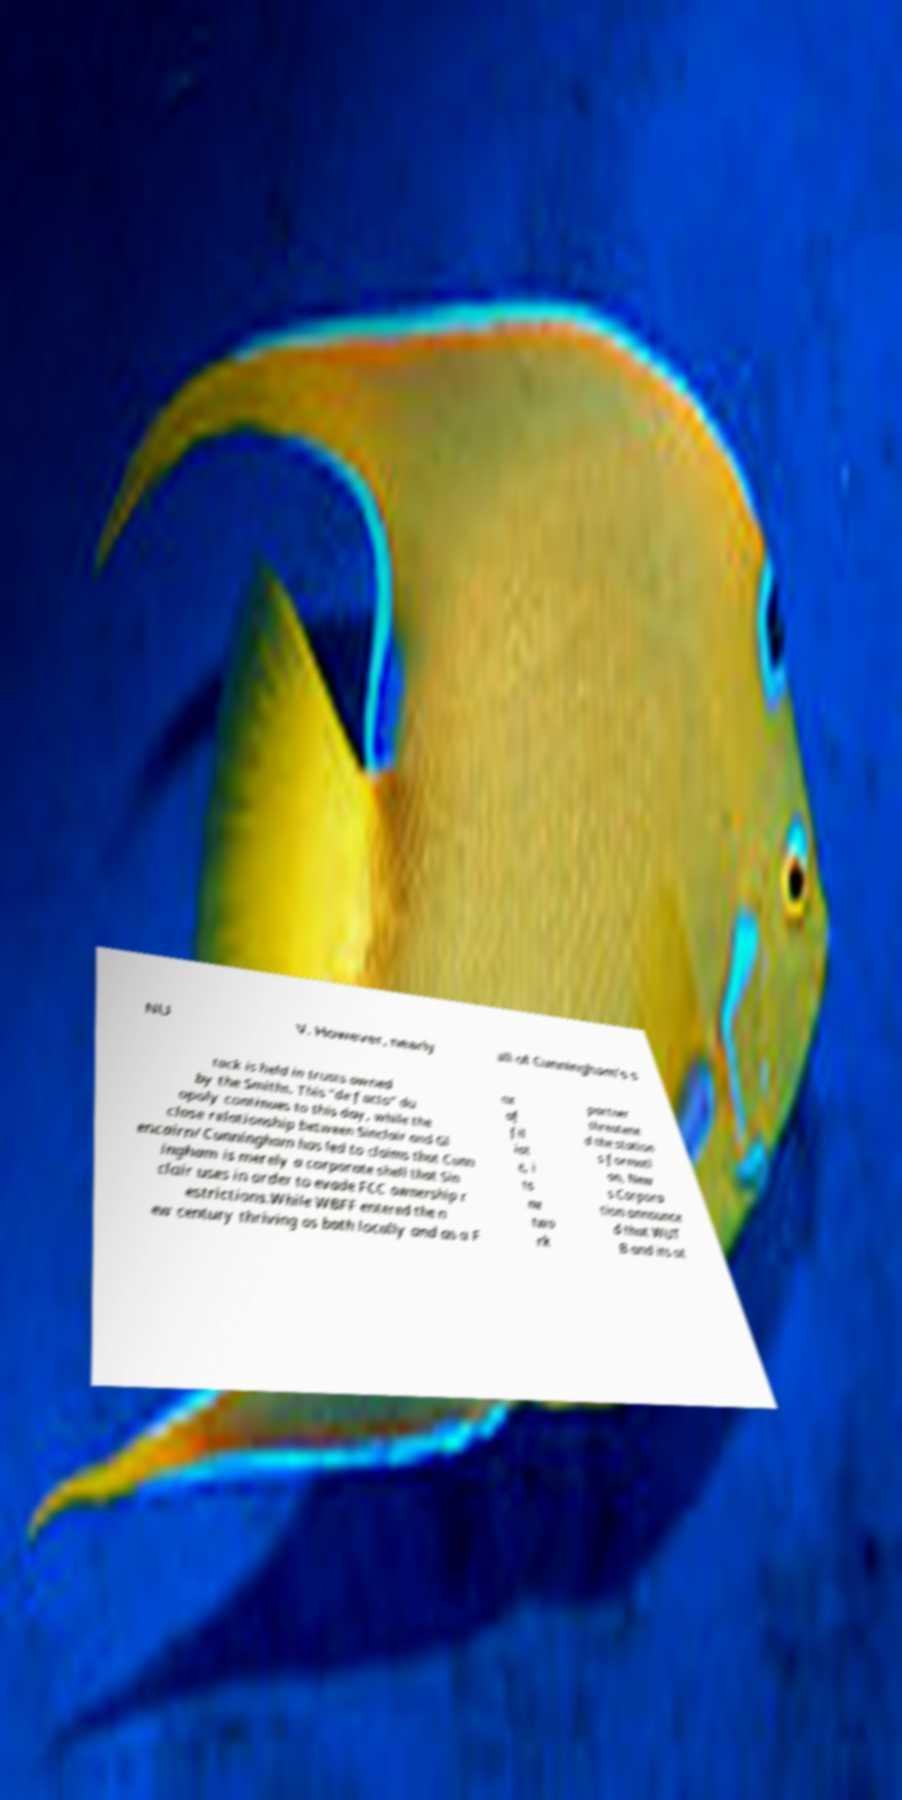Please identify and transcribe the text found in this image. NU V. However, nearly all of Cunningham's s tock is held in trusts owned by the Smiths. This "de facto" du opoly continues to this day, while the close relationship between Sinclair and Gl encairn/Cunningham has led to claims that Cunn ingham is merely a corporate shell that Sin clair uses in order to evade FCC ownership r estrictions.While WBFF entered the n ew century thriving as both locally and as a F ox af fil iat e, i ts ne two rk partner threatene d the station s formati on, New s Corpora tion announce d that WUT B and its ot 